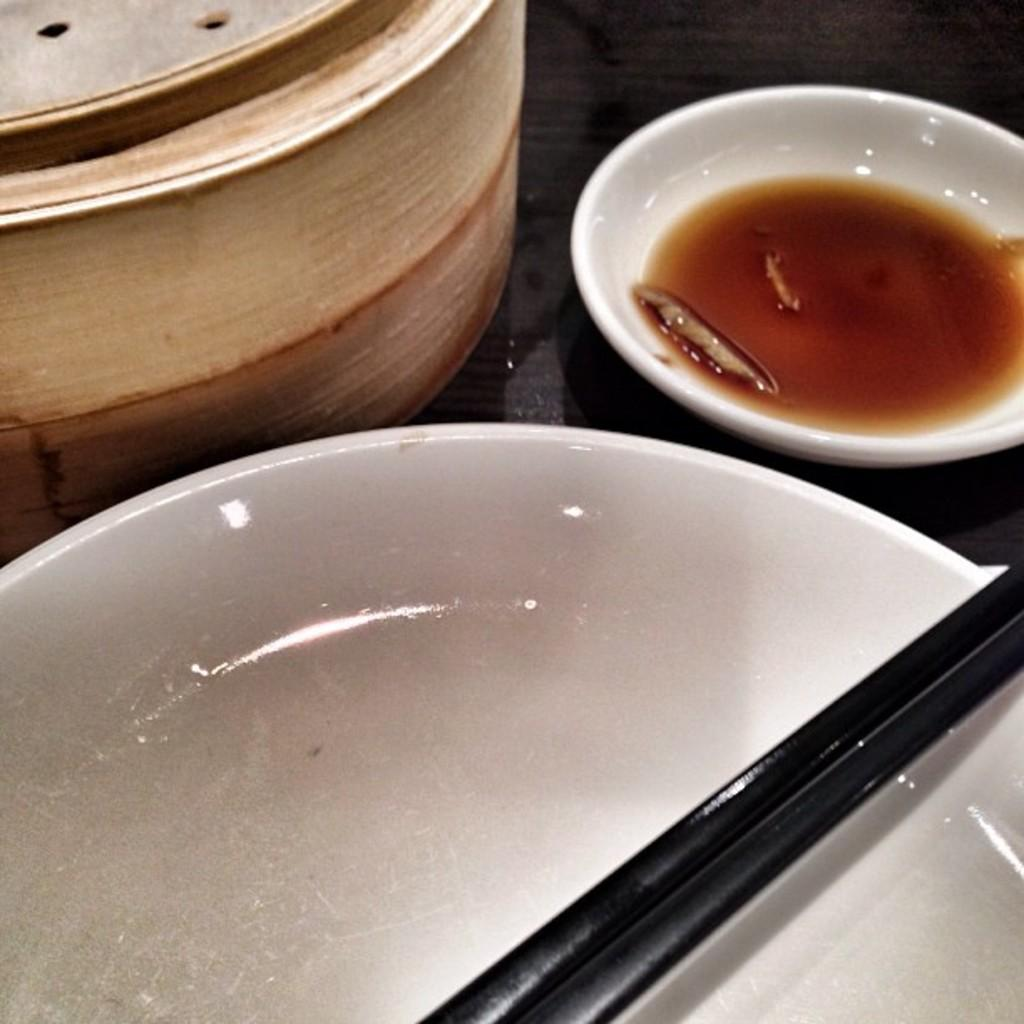What is present on the table in the image? There is a plate, 2 chopsticks, and a bowl of sauce on the table in the image. How many chopsticks are there in the image? There are 2 chopsticks in the image. What might be used to accompany the items on the table? The bowl of sauce in the image might be used to accompany the items on the table. What type of shock can be seen affecting the laborer in the image? There is no laborer present in the image, and therefore no shock can be observed. What type of stick is being used by the person in the image? There is no person or stick present in the image. 